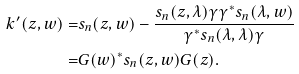Convert formula to latex. <formula><loc_0><loc_0><loc_500><loc_500>k ^ { \prime } ( z , w ) = & s _ { n } ( z , w ) - \frac { s _ { n } ( z , \lambda ) \gamma \gamma ^ { * } s _ { n } ( \lambda , w ) } { \gamma ^ { * } s _ { n } ( \lambda , \lambda ) \gamma } \\ = & G ( w ) ^ { * } s _ { n } ( z , w ) G ( z ) .</formula> 